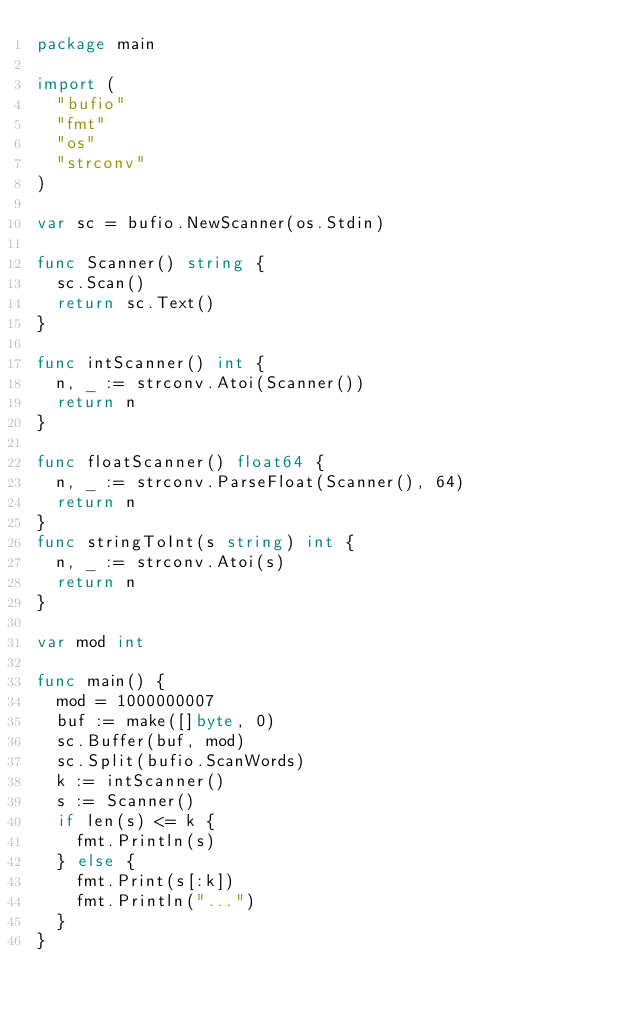Convert code to text. <code><loc_0><loc_0><loc_500><loc_500><_Go_>package main

import (
	"bufio"
	"fmt"
	"os"
	"strconv"
)

var sc = bufio.NewScanner(os.Stdin)

func Scanner() string {
	sc.Scan()
	return sc.Text()
}

func intScanner() int {
	n, _ := strconv.Atoi(Scanner())
	return n
}

func floatScanner() float64 {
	n, _ := strconv.ParseFloat(Scanner(), 64)
	return n
}
func stringToInt(s string) int {
	n, _ := strconv.Atoi(s)
	return n
}

var mod int

func main() {
	mod = 1000000007
	buf := make([]byte, 0)
	sc.Buffer(buf, mod)
	sc.Split(bufio.ScanWords)
	k := intScanner()
	s := Scanner()
	if len(s) <= k {
		fmt.Println(s)
	} else {
		fmt.Print(s[:k])
		fmt.Println("...")
	}
}
</code> 